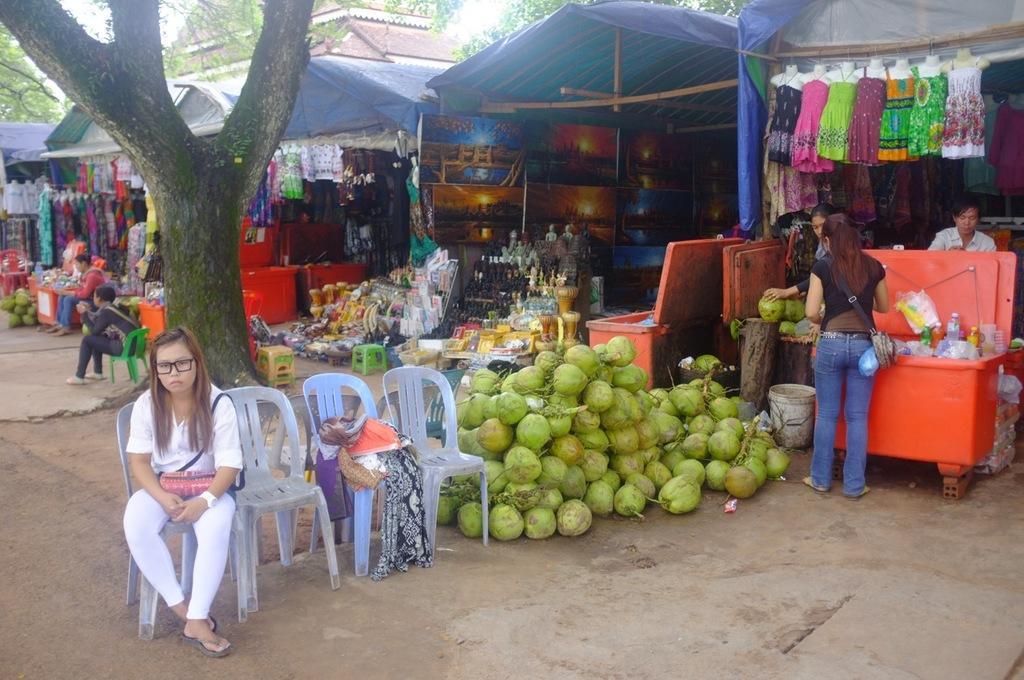Describe this image in one or two sentences. In this image there are few people. At the background there are stores. There is a tree. On the floor there is coconut. The woman is sitting on chair 